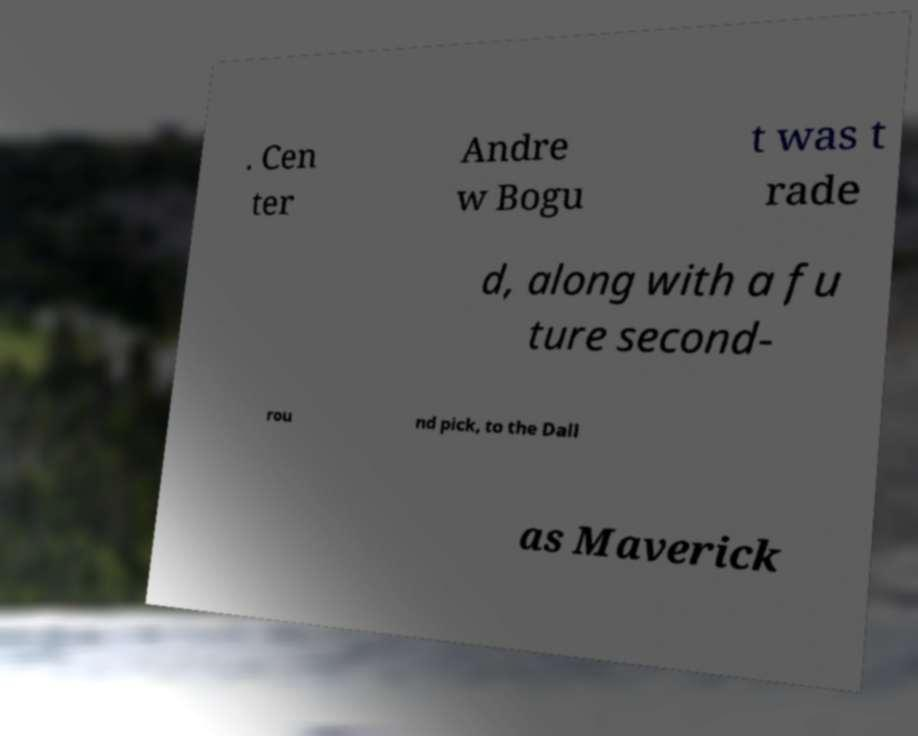Please identify and transcribe the text found in this image. . Cen ter Andre w Bogu t was t rade d, along with a fu ture second- rou nd pick, to the Dall as Maverick 